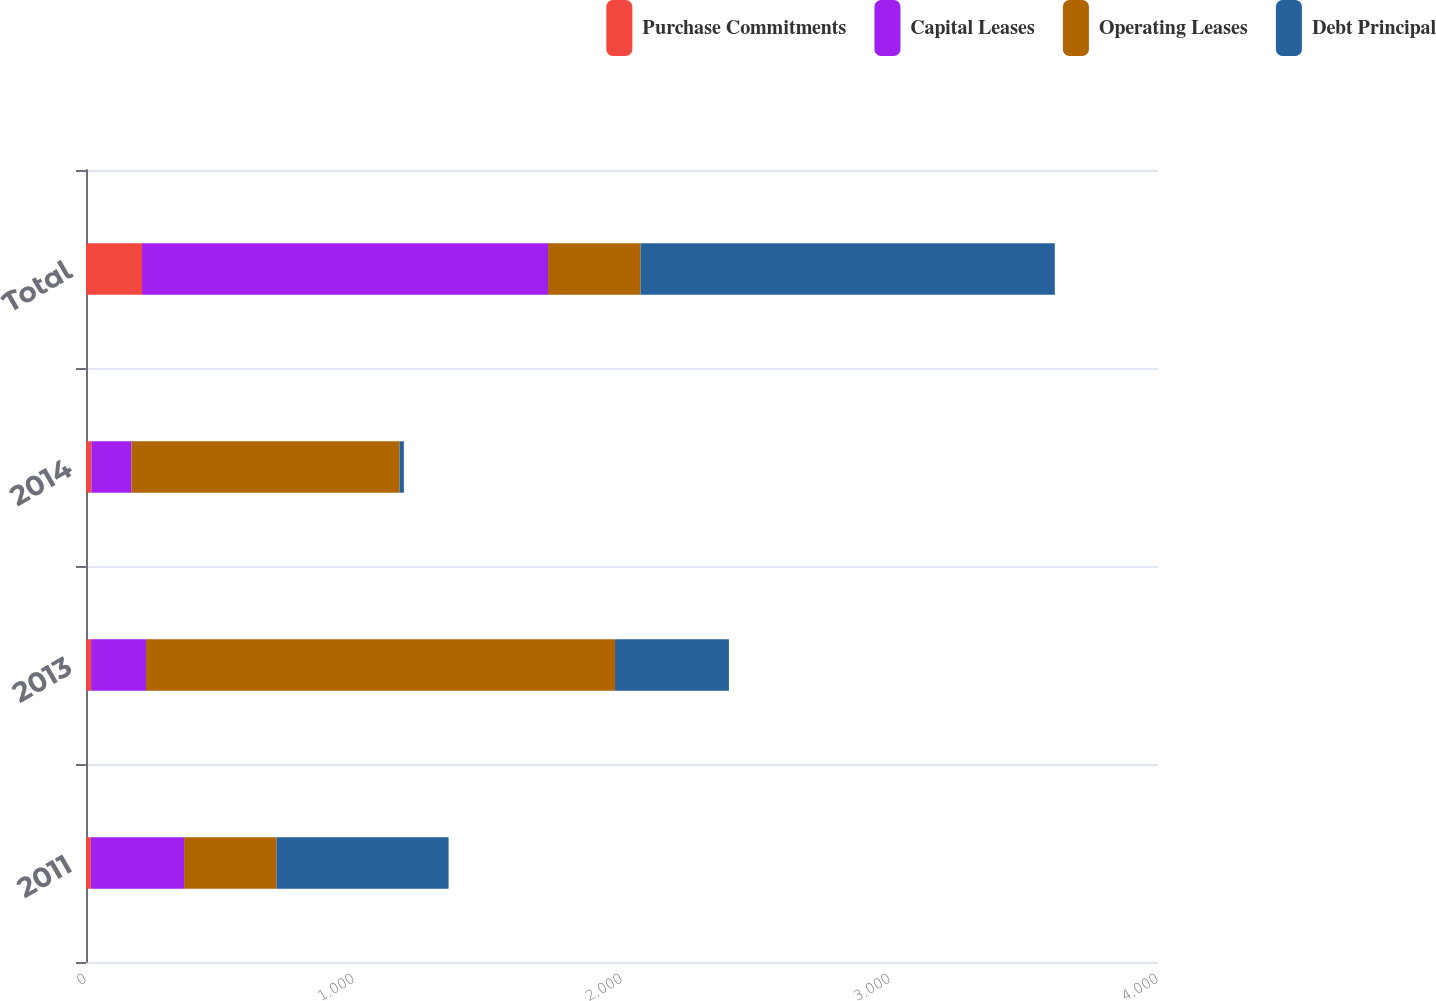Convert chart to OTSL. <chart><loc_0><loc_0><loc_500><loc_500><stacked_bar_chart><ecel><fcel>2011<fcel>2013<fcel>2014<fcel>Total<nl><fcel>Purchase Commitments<fcel>18<fcel>19<fcel>20<fcel>209<nl><fcel>Capital Leases<fcel>348<fcel>205<fcel>150<fcel>1515<nl><fcel>Operating Leases<fcel>345<fcel>1750<fcel>1000<fcel>345<nl><fcel>Debt Principal<fcel>642<fcel>425<fcel>16<fcel>1546<nl></chart> 